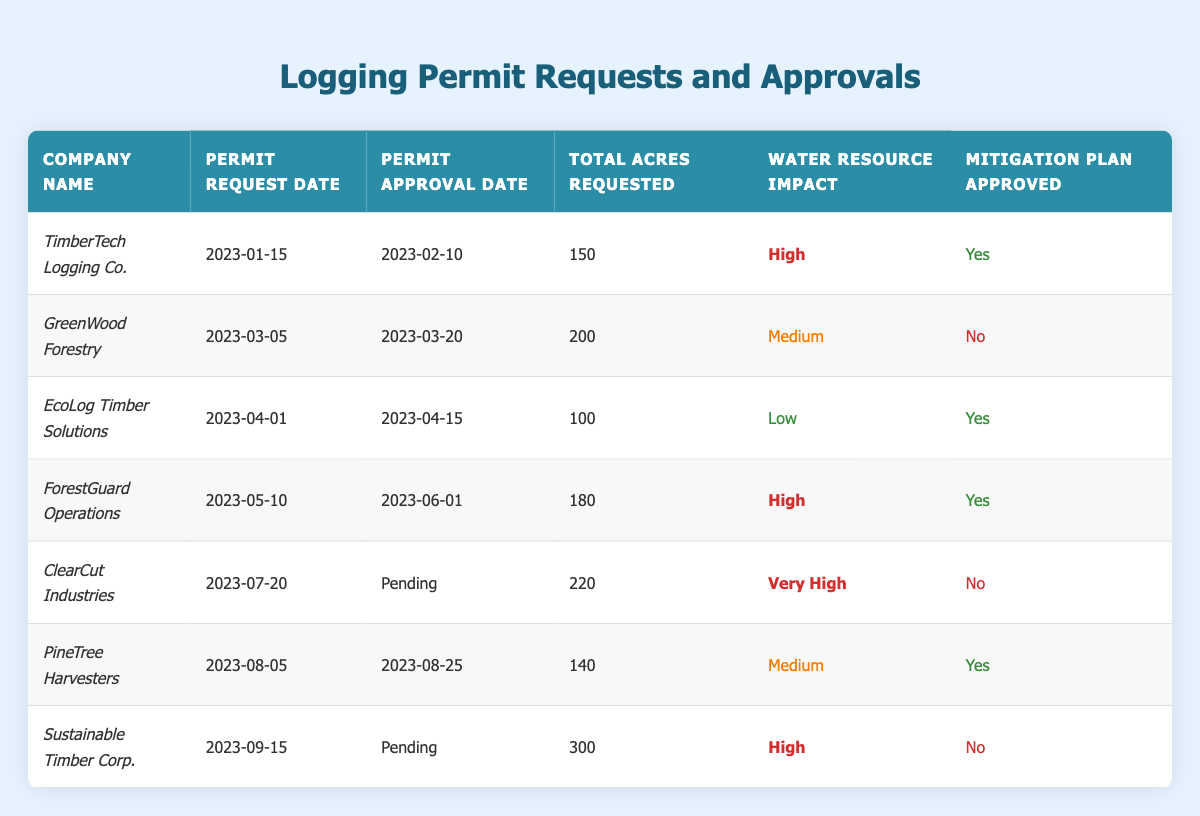What is the water resource impact classification of EcoLog Timber Solutions? From the table, we can see that EcoLog Timber Solutions has a water resource impact classified as "Low." This is directly stated under the "Water Resource Impact" column for that company.
Answer: Low Which company requested the highest total acres for logging? By examining the "Total Acres Requested" column, ClearCut Industries requested the highest total acres, which is 220 acres.
Answer: 220 acres How many companies have had their mitigation plans approved? We can identify the approved mitigation plans by checking the "Mitigation Plan Approved" column. There are four companies (TimberTech Logging Co., EcoLog Timber Solutions, ForestGuard Operations, and PineTree Harvesters) that have their plans marked as approved.
Answer: 4 What is the total amount of acres requested by all companies with a high water resource impact? First, we identify the companies with a high impact: TimberTech Logging Co. (150 acres) and ForestGuard Operations (180 acres). Adding these together gives us a total of 150 + 180 = 330 acres.
Answer: 330 acres Is there any company that still has a pending permit approval? By reviewing the "Permit Approval Date" column, both ClearCut Industries and Sustainable Timber Corp. have their approvals marked as "Pending." Thus, the answer is yes, there are companies with pending approvals.
Answer: Yes Which company has the lowest water resource impact? Looking at the "Water Resource Impact" column, EcoLog Timber Solutions has the lowest classification, labeled as "Low."
Answer: EcoLog Timber Solutions What proportion of the companies have received their mitigation plans approved? There are 7 companies in total, of which 4 have their mitigation plans approved. To find the proportion, we calculate 4 out of 7, which gives approximately 0.57 or 57%.
Answer: 57% How many total acres were requested by companies with a very high impact? From the table, only ClearCut Industries is classified as "Very High" and requested 220 acres. Therefore, the total requested is 220 acres.
Answer: 220 acres Do any of the companies have both a high water resource impact and a not-approved mitigation plan? Ice on the "Water Resource Impact" and "Mitigation Plan Approved" columns shows that ClearCut Industries is marked as "Very High" and not approved, while TimberTech Logging Co. and ForestGuard Operations (both labeled "High") have their plans approved. Therefore, only ClearCut Industries meets the criteria.
Answer: Yes What is the average total acres requested among the companies with their mitigation plans approved? The approved companies (TimberTech Logging Co. = 150 acres, EcoLog Timber Solutions = 100 acres, ForestGuard Operations = 180 acres, PineTree Harvesters = 140 acres) total to 150 + 100 + 180 + 140 = 570 acres. The average for these 4 companies is 570/4 = 142.5 acres.
Answer: 142.5 acres 